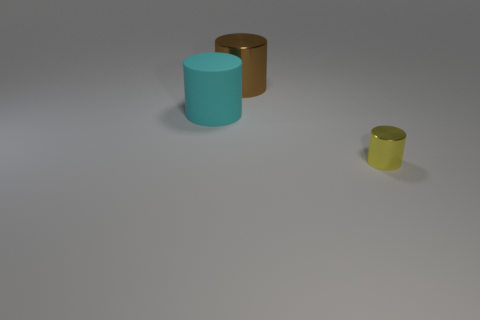Add 1 big purple shiny cylinders. How many objects exist? 4 Add 1 large brown things. How many large brown things exist? 2 Subtract 0 yellow spheres. How many objects are left? 3 Subtract all gray spheres. Subtract all tiny yellow cylinders. How many objects are left? 2 Add 2 small yellow metal cylinders. How many small yellow metal cylinders are left? 3 